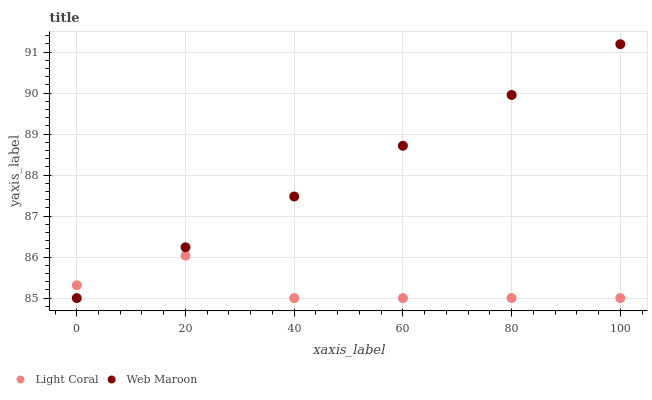Does Light Coral have the minimum area under the curve?
Answer yes or no. Yes. Does Web Maroon have the maximum area under the curve?
Answer yes or no. Yes. Does Web Maroon have the minimum area under the curve?
Answer yes or no. No. Is Web Maroon the smoothest?
Answer yes or no. Yes. Is Light Coral the roughest?
Answer yes or no. Yes. Is Web Maroon the roughest?
Answer yes or no. No. Does Light Coral have the lowest value?
Answer yes or no. Yes. Does Web Maroon have the highest value?
Answer yes or no. Yes. Does Web Maroon intersect Light Coral?
Answer yes or no. Yes. Is Web Maroon less than Light Coral?
Answer yes or no. No. Is Web Maroon greater than Light Coral?
Answer yes or no. No. 